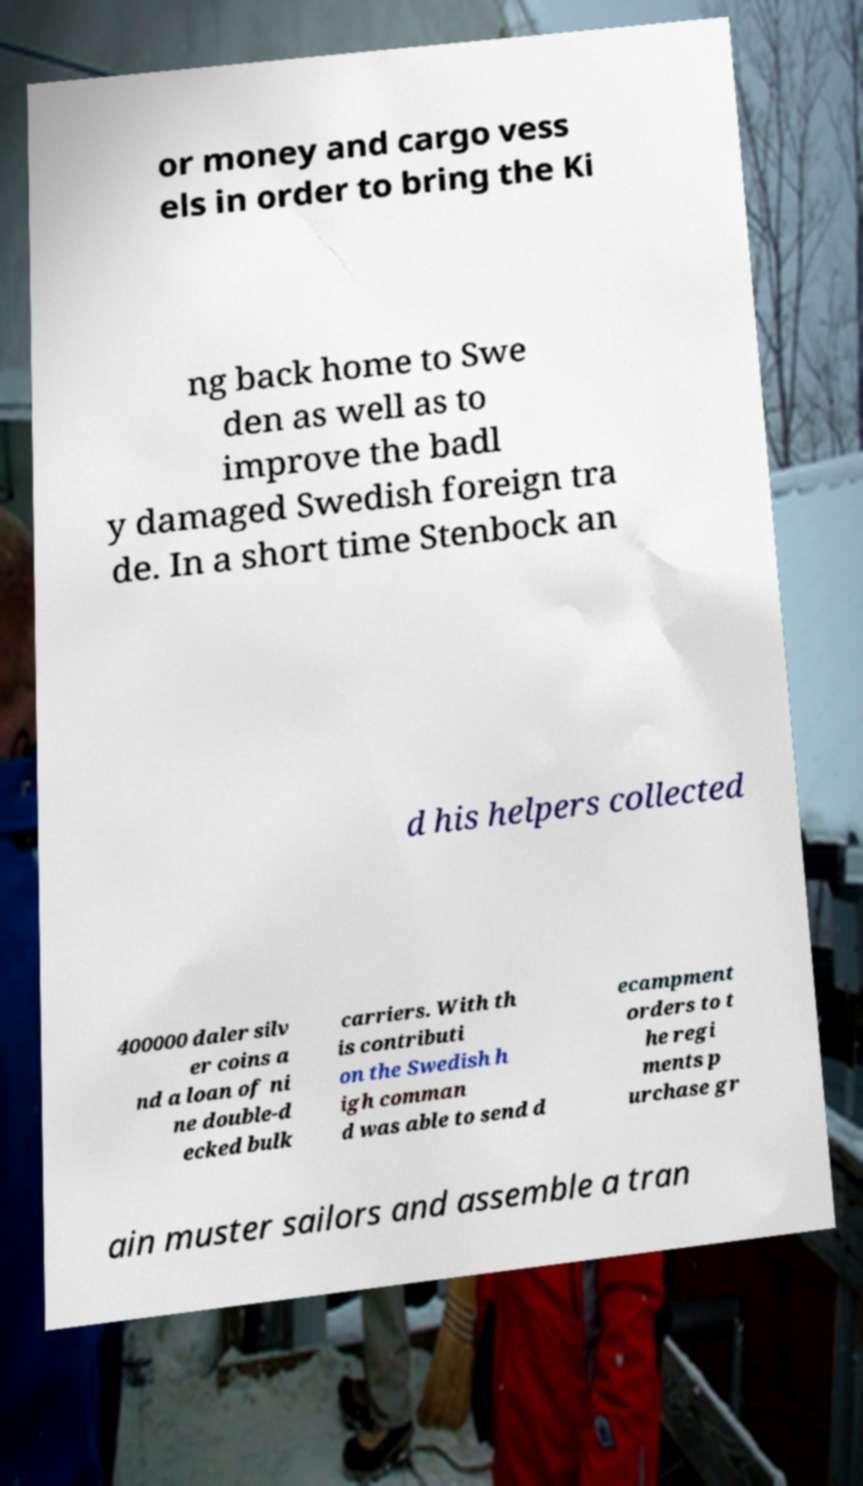Please identify and transcribe the text found in this image. or money and cargo vess els in order to bring the Ki ng back home to Swe den as well as to improve the badl y damaged Swedish foreign tra de. In a short time Stenbock an d his helpers collected 400000 daler silv er coins a nd a loan of ni ne double-d ecked bulk carriers. With th is contributi on the Swedish h igh comman d was able to send d ecampment orders to t he regi ments p urchase gr ain muster sailors and assemble a tran 